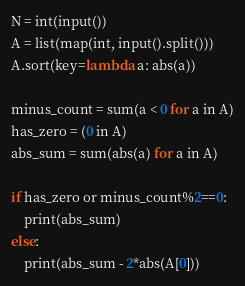<code> <loc_0><loc_0><loc_500><loc_500><_Python_>N = int(input())
A = list(map(int, input().split()))
A.sort(key=lambda a: abs(a))

minus_count = sum(a < 0 for a in A)
has_zero = (0 in A)
abs_sum = sum(abs(a) for a in A)

if has_zero or minus_count%2==0:
    print(abs_sum)
else:
    print(abs_sum - 2*abs(A[0]))
</code> 